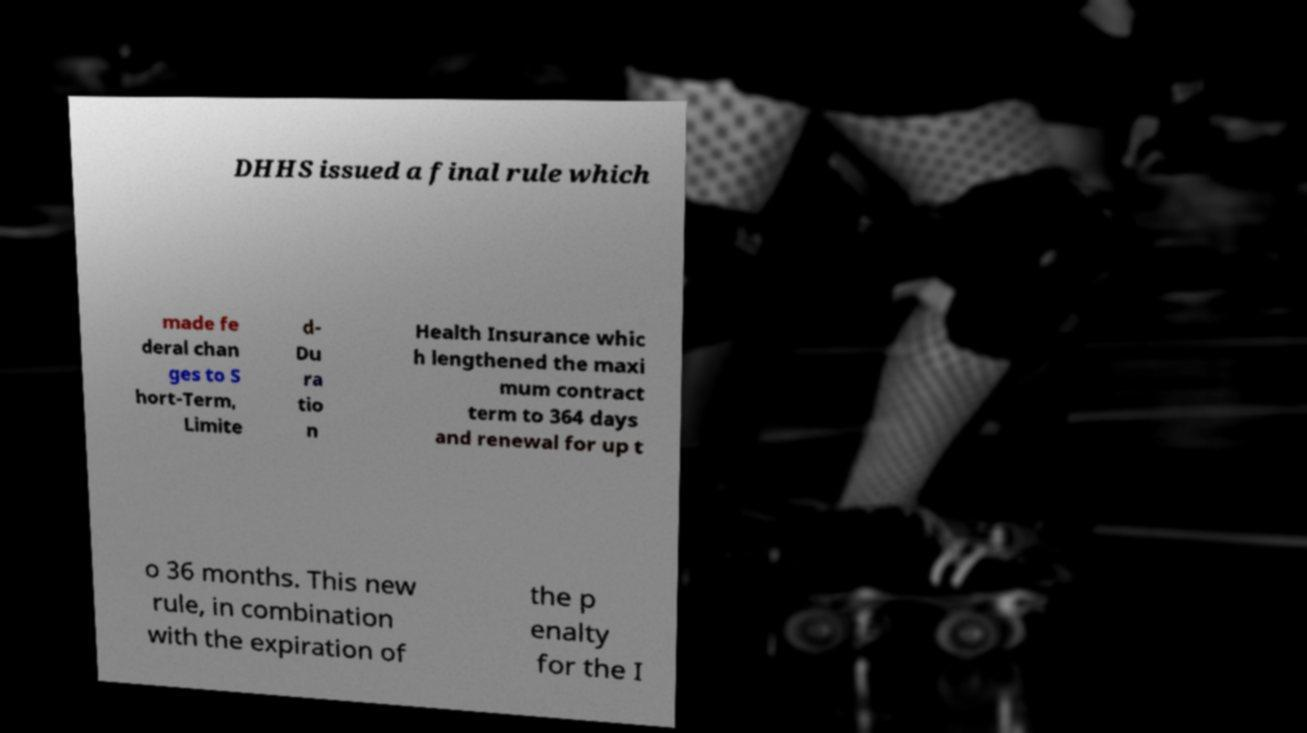Can you read and provide the text displayed in the image?This photo seems to have some interesting text. Can you extract and type it out for me? DHHS issued a final rule which made fe deral chan ges to S hort-Term, Limite d- Du ra tio n Health Insurance whic h lengthened the maxi mum contract term to 364 days and renewal for up t o 36 months. This new rule, in combination with the expiration of the p enalty for the I 